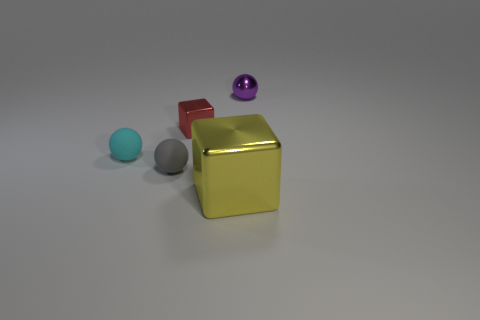Add 2 metallic spheres. How many objects exist? 7 Subtract all purple metallic spheres. How many spheres are left? 2 Subtract all cubes. How many objects are left? 3 Subtract all yellow cubes. Subtract all gray cylinders. How many cubes are left? 1 Subtract all yellow things. Subtract all large red rubber balls. How many objects are left? 4 Add 5 rubber objects. How many rubber objects are left? 7 Add 1 small shiny cubes. How many small shiny cubes exist? 2 Subtract 1 red cubes. How many objects are left? 4 